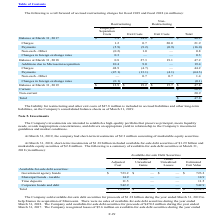According to Microchip Technology's financial document, What was the liability for restructuring and other exit costs that was included in accrued liabilities and other long-term liabilities as of 2019? According to the financial document, $47.8 million. The relevant text states: "iability for restructuring and other exit costs of $47.8 million is included in accrued liabilities and other long-term..." Also, What was the total balance as of 2017? According to the financial document, 40.2 (in millions). The relevant text states: "Balance at March 31, 2017 $ 5.4 $ 34.8 $ — $ 40.2..." Also, What were the total Additions due to Microsemi acquisition in 2018? According to the financial document, 19.4 (in millions). The relevant text states: "Additions due to Microsemi acquisition 10.4 9.0 — 19.4..." Also, can you calculate: What was the change in restructuring exit costs for Charges between 2017 and 2018? Based on the calculation: 27.3-0.7, the result is 26.6 (in millions). This is based on the information: "Charges 1.2 0.7 20.0 21.9 Balance at March 31, 2018 0.8 27.3 19.1 47.2..." The key data points involved are: 0.7, 27.3. Also, How many years did the total balance exceed $45 million? Counting the relevant items in the document: 2019, 2018, I find 2 instances. The key data points involved are: 2018, 2019. Also, can you calculate: What was the percentage change in the total balance between 2018 and 2019? To answer this question, I need to perform calculations using the financial data. The calculation is: (47.8-47.2)/47.2, which equals 1.27 (percentage). This is based on the information: "Balance at March 31, 2019 $ 12.9 $ 19.2 $ 15.7 $ 47.8 Balance at March 31, 2018 0.8 27.3 19.1 47.2..." The key data points involved are: 47.2, 47.8. 